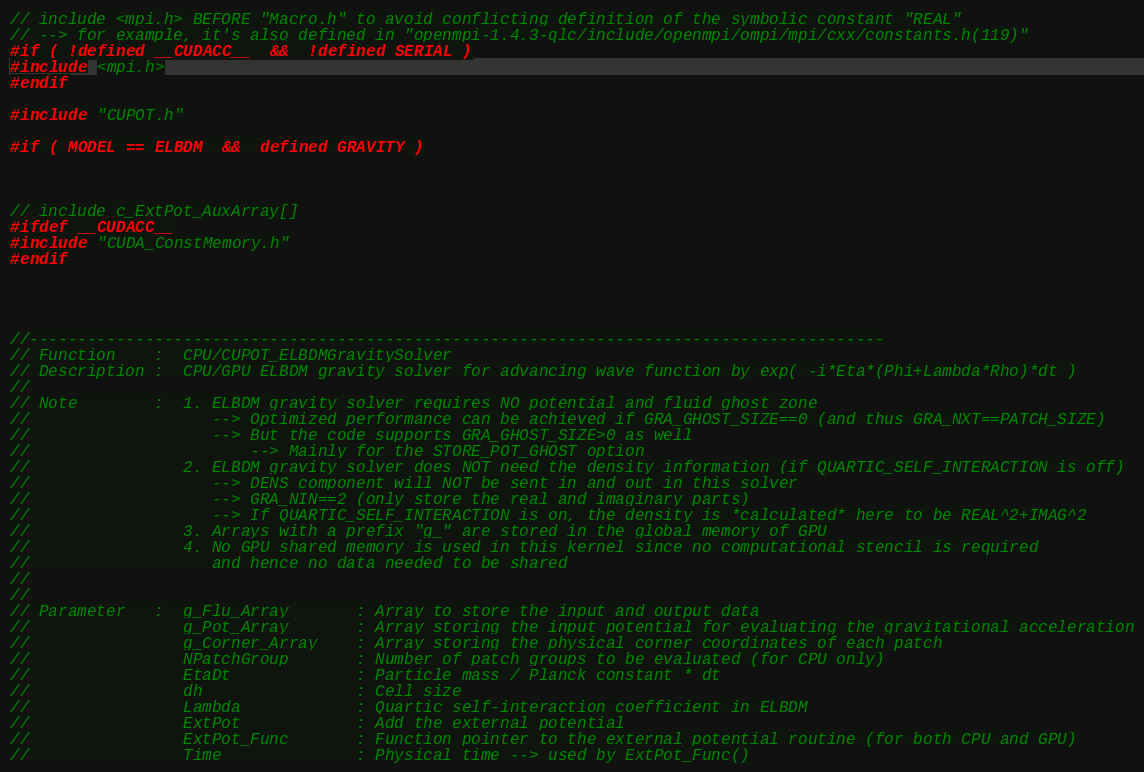Convert code to text. <code><loc_0><loc_0><loc_500><loc_500><_Cuda_>// include <mpi.h> BEFORE "Macro.h" to avoid conflicting definition of the symbolic constant "REAL"
// --> for example, it's also defined in "openmpi-1.4.3-qlc/include/openmpi/ompi/mpi/cxx/constants.h(119)"
#if ( !defined __CUDACC__  &&  !defined SERIAL )
#include <mpi.h>
#endif

#include "CUPOT.h"

#if ( MODEL == ELBDM  &&  defined GRAVITY )



// include c_ExtPot_AuxArray[]
#ifdef __CUDACC__
#include "CUDA_ConstMemory.h"
#endif




//-----------------------------------------------------------------------------------------
// Function    :  CPU/CUPOT_ELBDMGravitySolver
// Description :  CPU/GPU ELBDM gravity solver for advancing wave function by exp( -i*Eta*(Phi+Lambda*Rho)*dt )
//
// Note        :  1. ELBDM gravity solver requires NO potential and fluid ghost zone
//                   --> Optimized performance can be achieved if GRA_GHOST_SIZE==0 (and thus GRA_NXT==PATCH_SIZE)
//                   --> But the code supports GRA_GHOST_SIZE>0 as well
//                       --> Mainly for the STORE_POT_GHOST option
//                2. ELBDM gravity solver does NOT need the density information (if QUARTIC_SELF_INTERACTION is off)
//                   --> DENS component will NOT be sent in and out in this solver
//                   --> GRA_NIN==2 (only store the real and imaginary parts)
//                   --> If QUARTIC_SELF_INTERACTION is on, the density is *calculated* here to be REAL^2+IMAG^2
//                3. Arrays with a prefix "g_" are stored in the global memory of GPU
//                4. No GPU shared memory is used in this kernel since no computational stencil is required
//                   and hence no data needed to be shared
//
//
// Parameter   :  g_Flu_Array       : Array to store the input and output data
//                g_Pot_Array       : Array storing the input potential for evaluating the gravitational acceleration
//                g_Corner_Array    : Array storing the physical corner coordinates of each patch
//                NPatchGroup       : Number of patch groups to be evaluated (for CPU only)
//                EtaDt             : Particle mass / Planck constant * dt
//                dh                : Cell size
//                Lambda            : Quartic self-interaction coefficient in ELBDM
//                ExtPot            : Add the external potential
//                ExtPot_Func       : Function pointer to the external potential routine (for both CPU and GPU)
//                Time              : Physical time --> used by ExtPot_Func()</code> 